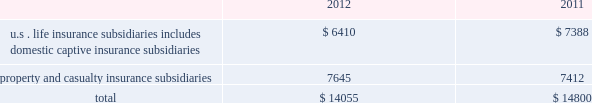Table of contents statutory surplus the table below sets forth statutory surplus for the company 2019s insurance companies as of december 31 , 2012 and 2011: .
Statutory capital and surplus for the u.s .
Life insurance subsidiaries , including domestic captive insurance subsidiaries , decreased by $ 978 , primarily due to variable annuity surplus impacts of approximately $ 425 , a $ 200 increase in reserves on a change in valuation basis , $ 200 transfer of the mutual funds business from the u.s .
Life insurance companies to the life holding company , and an increase in the asset valuation reserve of $ 115 .
As a result of the january 2013 statutory gain from the sale of the retirement plans and individual life businesses , the company's pro forma january 2 , 2013 u.s .
Life statutory surplus was estimated to be $ 8.1 billion , before approximately $ 1.5 billion in extraordinary dividends and return of capital to hfsg holding company .
Statutory capital and surplus for the property and casualty insurance subsidiaries increased by $ 233 , primarily due to statutory net income , after tax , of $ 727 , unrealized gains of $ 249 , and an increase in statutory admitted deferred tax assets of $ 77 , capital contributions of $ 14 , and an increase of statutory admitted assets of $ 7 , partially offset by dividends to the hfsg holding company of $ 841 .
Both net income and dividends are net of interest payments and dividends , respectively , on an intercompany note between hartford holdings , inc .
And hartford fire insurance company .
The company also holds regulatory capital and surplus for its operations in japan .
Under the accounting practices and procedures governed by japanese regulatory authorities , the company 2019s statutory capital and surplus was $ 1.1 billion and $ 1.3 billion as of december 31 , 2012 and 2011 , respectively .
Statutory capital the company 2019s stockholders 2019 equity , as prepared using u.s .
Generally accepted accounting principles ( 201cu.s .
Gaap 201d ) was $ 22.4 billion as of december 31 , 2012 .
The company 2019s estimated aggregate statutory capital and surplus , as prepared in accordance with the national association of insurance commissioners 2019 accounting practices and procedures manual ( 201cu.s .
Stat 201d ) was $ 14.1 billion as of december 31 , 2012 .
Significant differences between u.s .
Gaap stockholders 2019 equity and aggregate statutory capital and surplus prepared in accordance with u.s .
Stat include the following : 2022 u.s .
Stat excludes equity of non-insurance and foreign insurance subsidiaries not held by u.s .
Insurance subsidiaries .
2022 costs incurred by the company to acquire insurance policies are deferred under u.s .
Gaap while those costs are expensed immediately under u.s .
2022 temporary differences between the book and tax basis of an asset or liability which are recorded as deferred tax assets are evaluated for recoverability under u.s .
Gaap while those amounts deferred are subject to limitations under u.s .
Stat .
2022 the assumptions used in the determination of life benefit reserves is prescribed under u.s .
Stat , while the assumptions used under u.s .
Gaap are generally the company 2019s best estimates .
The methodologies for determining life insurance reserve amounts may also be different .
For example , reserving for living benefit reserves under u.s .
Stat is generally addressed by the commissioners 2019 annuity reserving valuation methodology and the related actuarial guidelines , while under u.s .
Gaap , those same living benefits may be considered embedded derivatives and recorded at fair value or they may be considered sop 03-1 reserves .
The sensitivity of these life insurance reserves to changes in equity markets , as applicable , will be different between u.s .
Gaap and u.s .
Stat .
2022 the difference between the amortized cost and fair value of fixed maturity and other investments , net of tax , is recorded as an increase or decrease to the carrying value of the related asset and to equity under u.s .
Gaap , while u.s .
Stat only records certain securities at fair value , such as equity securities and certain lower rated bonds required by the naic to be recorded at the lower of amortized cost or fair value .
2022 u.s .
Stat for life insurance companies establishes a formula reserve for realized and unrealized losses due to default and equity risks associated with certain invested assets ( the asset valuation reserve ) , while u.s .
Gaap does not .
Also , for those realized gains and losses caused by changes in interest rates , u.s .
Stat for life insurance companies defers and amortizes the gains and losses , caused by changes in interest rates , into income over the original life to maturity of the asset sold ( the interest maintenance reserve ) while u.s .
Gaap does not .
2022 goodwill arising from the acquisition of a business is tested for recoverability on an annual basis ( or more frequently , as necessary ) for u.s .
Gaap , while under u.s .
Stat goodwill is amortized over a period not to exceed 10 years and the amount of goodwill is limited. .
What is the percentage change in statutory surplus from 2011 to 2012? 
Computations: ((14055 - 14800) / 14800)
Answer: -0.05034. 